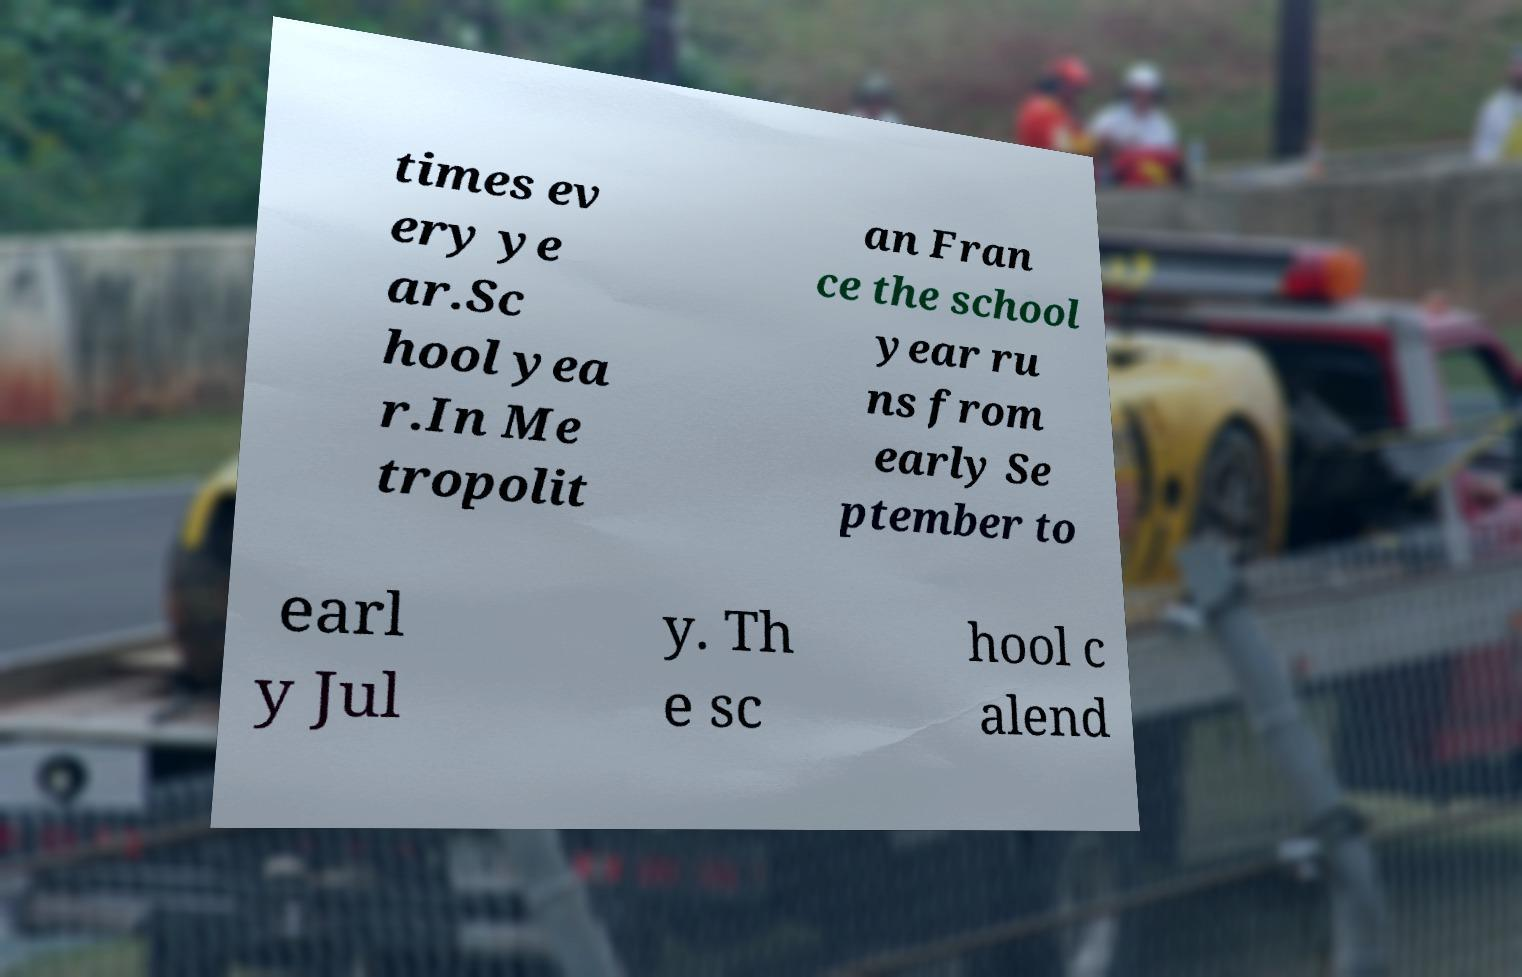Please identify and transcribe the text found in this image. times ev ery ye ar.Sc hool yea r.In Me tropolit an Fran ce the school year ru ns from early Se ptember to earl y Jul y. Th e sc hool c alend 